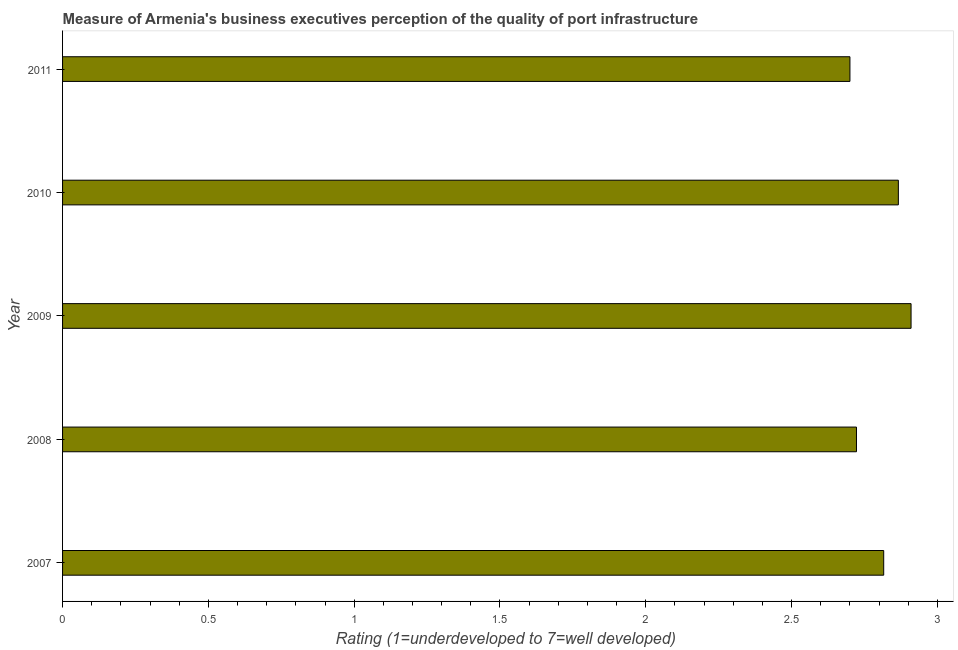Does the graph contain any zero values?
Ensure brevity in your answer.  No. Does the graph contain grids?
Your answer should be very brief. No. What is the title of the graph?
Your response must be concise. Measure of Armenia's business executives perception of the quality of port infrastructure. What is the label or title of the X-axis?
Ensure brevity in your answer.  Rating (1=underdeveloped to 7=well developed) . What is the rating measuring quality of port infrastructure in 2007?
Offer a terse response. 2.82. Across all years, what is the maximum rating measuring quality of port infrastructure?
Your answer should be compact. 2.91. In which year was the rating measuring quality of port infrastructure maximum?
Your answer should be compact. 2009. In which year was the rating measuring quality of port infrastructure minimum?
Provide a short and direct response. 2011. What is the sum of the rating measuring quality of port infrastructure?
Your response must be concise. 14.01. What is the difference between the rating measuring quality of port infrastructure in 2008 and 2011?
Give a very brief answer. 0.02. What is the average rating measuring quality of port infrastructure per year?
Provide a short and direct response. 2.8. What is the median rating measuring quality of port infrastructure?
Make the answer very short. 2.82. Do a majority of the years between 2009 and 2010 (inclusive) have rating measuring quality of port infrastructure greater than 2.2 ?
Your answer should be compact. Yes. What is the ratio of the rating measuring quality of port infrastructure in 2007 to that in 2008?
Keep it short and to the point. 1.03. Is the rating measuring quality of port infrastructure in 2009 less than that in 2010?
Offer a terse response. No. What is the difference between the highest and the second highest rating measuring quality of port infrastructure?
Your response must be concise. 0.04. What is the difference between the highest and the lowest rating measuring quality of port infrastructure?
Give a very brief answer. 0.21. In how many years, is the rating measuring quality of port infrastructure greater than the average rating measuring quality of port infrastructure taken over all years?
Make the answer very short. 3. How many years are there in the graph?
Keep it short and to the point. 5. Are the values on the major ticks of X-axis written in scientific E-notation?
Your answer should be compact. No. What is the Rating (1=underdeveloped to 7=well developed)  of 2007?
Give a very brief answer. 2.82. What is the Rating (1=underdeveloped to 7=well developed)  of 2008?
Your answer should be compact. 2.72. What is the Rating (1=underdeveloped to 7=well developed)  in 2009?
Ensure brevity in your answer.  2.91. What is the Rating (1=underdeveloped to 7=well developed)  in 2010?
Provide a short and direct response. 2.87. What is the Rating (1=underdeveloped to 7=well developed)  of 2011?
Your answer should be very brief. 2.7. What is the difference between the Rating (1=underdeveloped to 7=well developed)  in 2007 and 2008?
Provide a succinct answer. 0.09. What is the difference between the Rating (1=underdeveloped to 7=well developed)  in 2007 and 2009?
Give a very brief answer. -0.09. What is the difference between the Rating (1=underdeveloped to 7=well developed)  in 2007 and 2010?
Your response must be concise. -0.05. What is the difference between the Rating (1=underdeveloped to 7=well developed)  in 2007 and 2011?
Offer a very short reply. 0.12. What is the difference between the Rating (1=underdeveloped to 7=well developed)  in 2008 and 2009?
Provide a succinct answer. -0.19. What is the difference between the Rating (1=underdeveloped to 7=well developed)  in 2008 and 2010?
Offer a terse response. -0.14. What is the difference between the Rating (1=underdeveloped to 7=well developed)  in 2008 and 2011?
Offer a very short reply. 0.02. What is the difference between the Rating (1=underdeveloped to 7=well developed)  in 2009 and 2010?
Provide a short and direct response. 0.04. What is the difference between the Rating (1=underdeveloped to 7=well developed)  in 2009 and 2011?
Your answer should be compact. 0.21. What is the difference between the Rating (1=underdeveloped to 7=well developed)  in 2010 and 2011?
Offer a terse response. 0.17. What is the ratio of the Rating (1=underdeveloped to 7=well developed)  in 2007 to that in 2008?
Your answer should be compact. 1.03. What is the ratio of the Rating (1=underdeveloped to 7=well developed)  in 2007 to that in 2010?
Make the answer very short. 0.98. What is the ratio of the Rating (1=underdeveloped to 7=well developed)  in 2007 to that in 2011?
Provide a short and direct response. 1.04. What is the ratio of the Rating (1=underdeveloped to 7=well developed)  in 2008 to that in 2009?
Your response must be concise. 0.94. What is the ratio of the Rating (1=underdeveloped to 7=well developed)  in 2009 to that in 2010?
Give a very brief answer. 1.01. What is the ratio of the Rating (1=underdeveloped to 7=well developed)  in 2009 to that in 2011?
Your answer should be very brief. 1.08. What is the ratio of the Rating (1=underdeveloped to 7=well developed)  in 2010 to that in 2011?
Offer a very short reply. 1.06. 